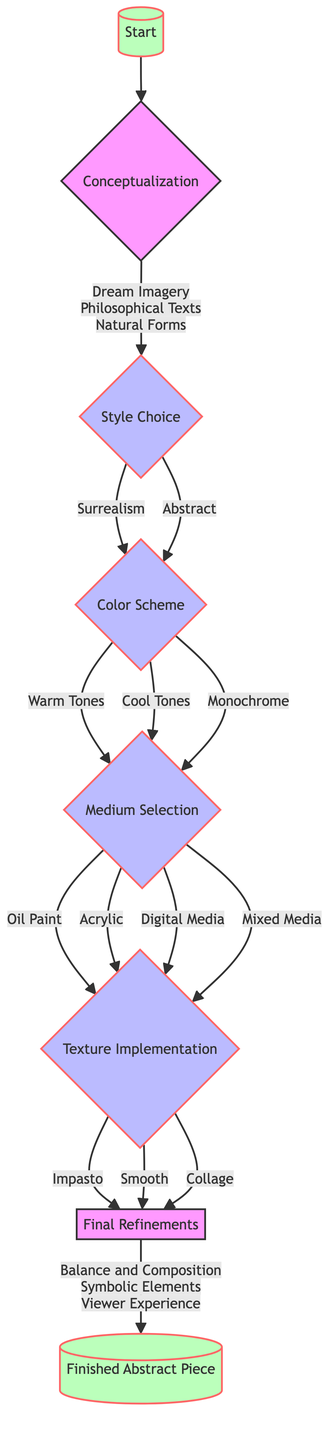What are the initial inputs for the concept? The diagram shows that the initial inputs for the concept are "Dream Imagery," "Philosophical Texts," and "Natural Forms." These inputs lead to the next step, which is the Style Choice.
Answer: Dream Imagery, Philosophical Texts, Natural Forms What are the three options for the color scheme? According to the diagram, the options for the color scheme include "Warm Tones," "Cool Tones," and "Monochrome." Each choice leads to the next step, which is Medium Selection.
Answer: Warm Tones, Cool Tones, Monochrome What comes after the Style Choice decision point? From the Style Choice decision point, the two branches are Surrealism and Abstract, both leading to the Color Scheme.
Answer: Color Scheme How many techniques are listed for Surrealism? The diagram lists two techniques under Surrealism: "Double Exposure" and "Juxtaposition." This can be counted directly from the visual node.
Answer: 2 What is the final step after the final refinements? The diagram shows that the final step following the final refinements is "Completion," which signifies the end of the creative process.
Answer: Completion Which mediums lead to texture implementation? The mediums listed that lead to texture implementation are "Oil Paint," "Acrylic," "Digital Media," and "Mixed Media." This is derived from the Medium Selection node in the diagram.
Answer: Oil Paint, Acrylic, Digital Media, Mixed Media What are the considerations in the final refinements? The diagram specifies that the considerations in the final refinements are "Balance and Composition," "Symbolic Elements," and "Viewer Experience." These considerations are crucial for the finishing touches of the piece.
Answer: Balance and Composition, Symbolic Elements, Viewer Experience If a choice is made for "Collage" texture, what is the next step? The diagram indicates that if "Collage" is chosen in the Texture Implementation, it will lead directly to the Final Refinements, where further consideration is made before completion.
Answer: Final Refinements 